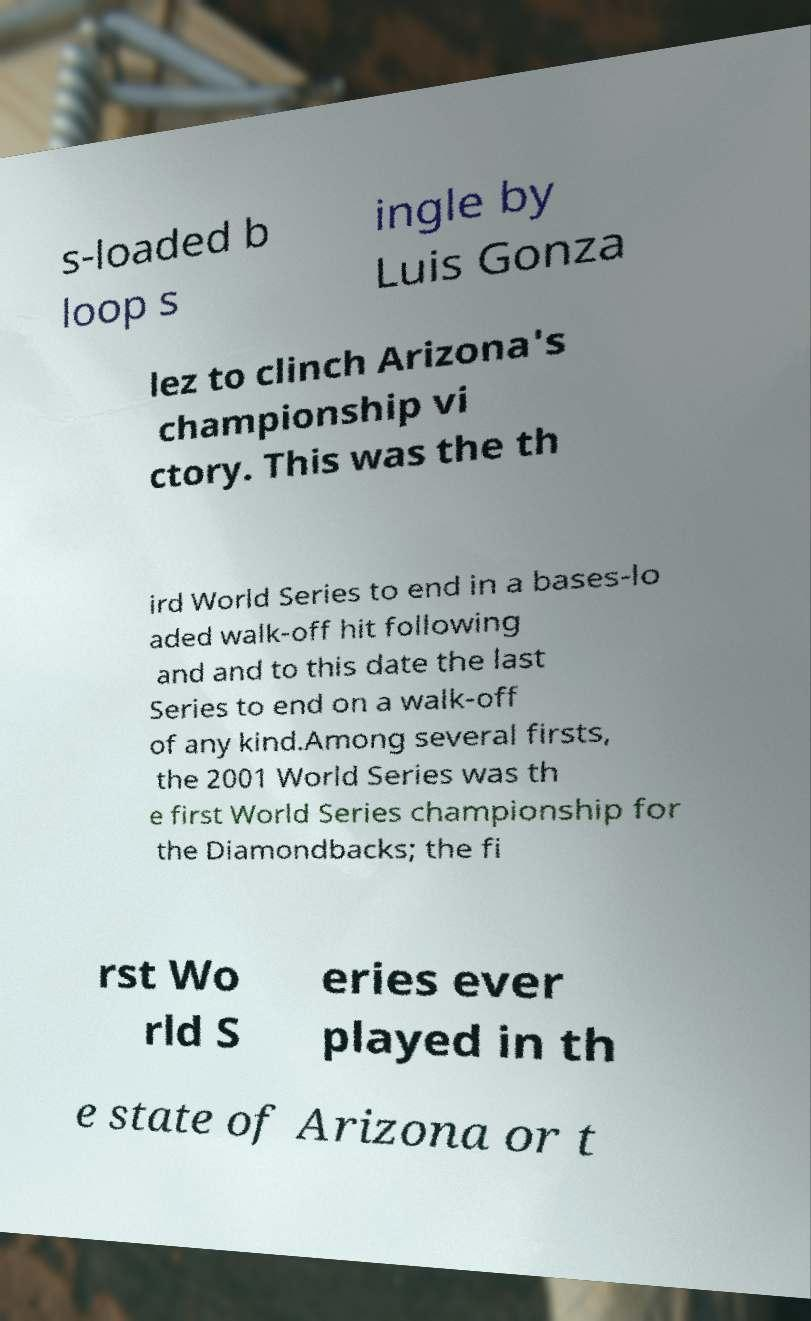Please identify and transcribe the text found in this image. s-loaded b loop s ingle by Luis Gonza lez to clinch Arizona's championship vi ctory. This was the th ird World Series to end in a bases-lo aded walk-off hit following and and to this date the last Series to end on a walk-off of any kind.Among several firsts, the 2001 World Series was th e first World Series championship for the Diamondbacks; the fi rst Wo rld S eries ever played in th e state of Arizona or t 